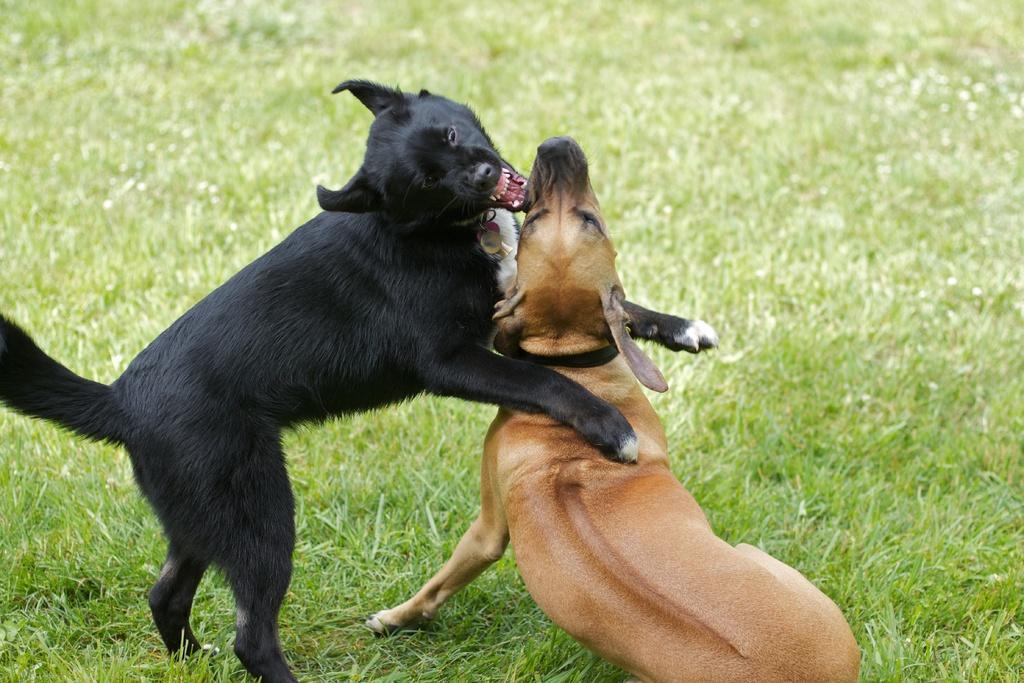How would you summarize this image in a sentence or two? There is a black color dog which has placed first two legs of it on an another dog which is in brown color in front of it and the ground is greenery. 